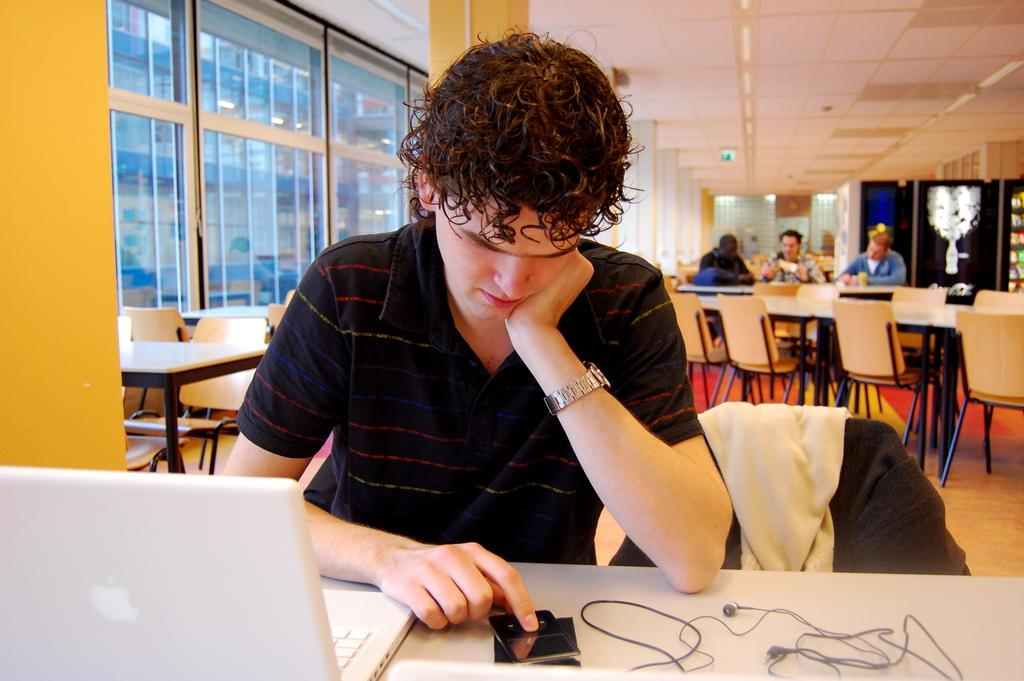What is the man in the image doing? The man is sitting in front of a table. What objects are on the table in the image? There is a laptop and a cellphone on the table. Can you describe the background of the image? There are people sitting in the background, and a roof and a window are visible. What type of care does the man provide to the root in the image? There is no root present in the image, and the man is not providing any care. 